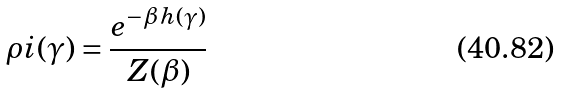<formula> <loc_0><loc_0><loc_500><loc_500>\rho i ( \gamma ) = \frac { e ^ { - \beta \, h ( \gamma ) } } { Z ( \beta ) }</formula> 